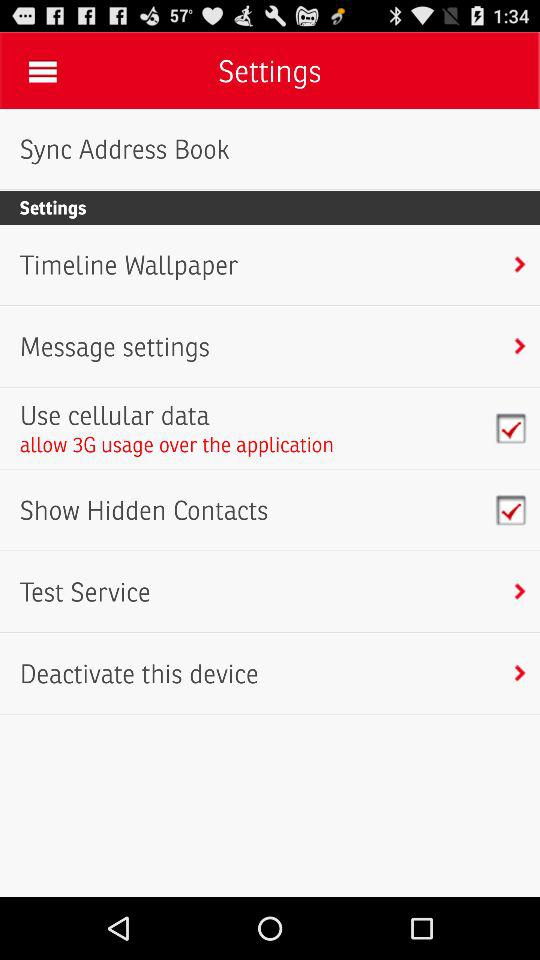How much usage is allowed over the application? The usage allowed over the application is 3G. 